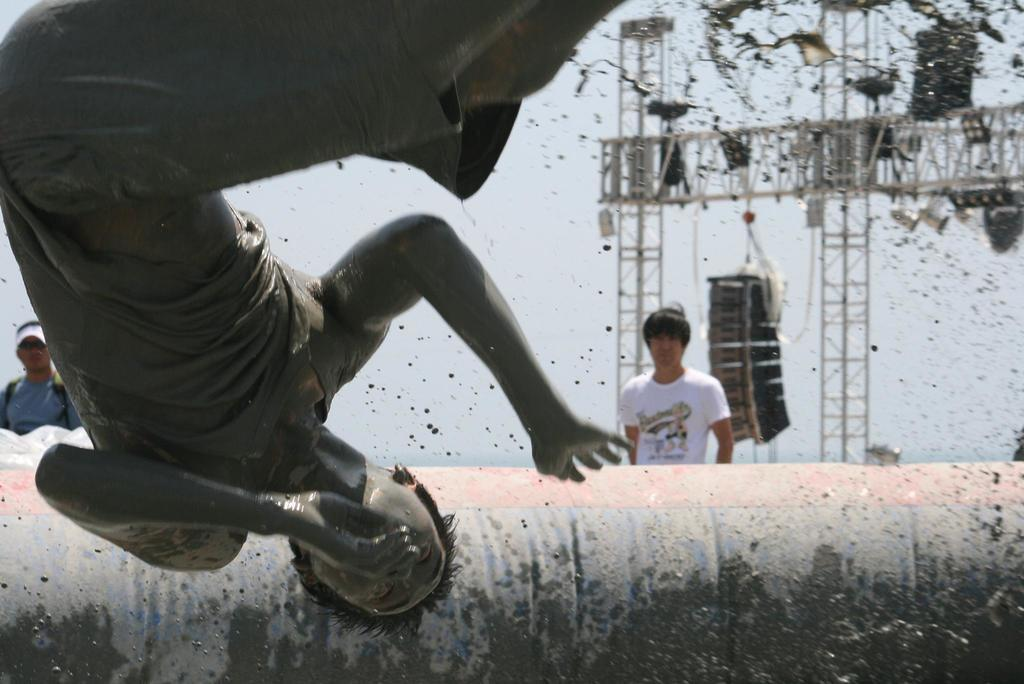How many people are in the image? There are three people in the image. Can you describe the attire of one of the men? One of the men is wearing a cap and goggles. What can be seen in the background of the image? There are objects visible in the background of the image. What type of cake is being served at the party in the image? There is no cake or party present in the image; it features three people, one of whom is wearing a cap and goggles. What liquid is being poured into the glasses at the party in the image? There is no party or liquid being poured in the image. 